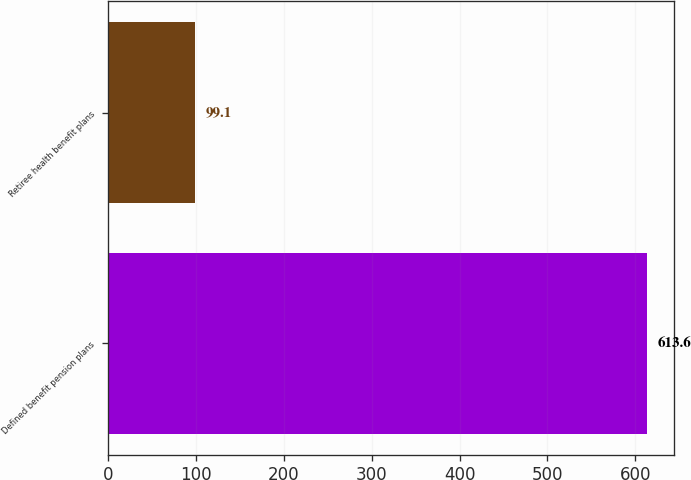Convert chart to OTSL. <chart><loc_0><loc_0><loc_500><loc_500><bar_chart><fcel>Defined benefit pension plans<fcel>Retiree health benefit plans<nl><fcel>613.6<fcel>99.1<nl></chart> 